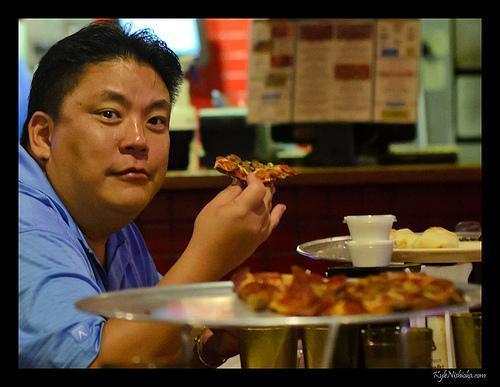How many people do you see?
Give a very brief answer. 1. 